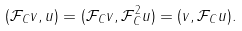Convert formula to latex. <formula><loc_0><loc_0><loc_500><loc_500>( \mathcal { F } _ { C } v , u ) = ( \mathcal { F } _ { C } v , \mathcal { F } _ { C } ^ { 2 } u ) = ( v , \mathcal { F } _ { C } u ) .</formula> 